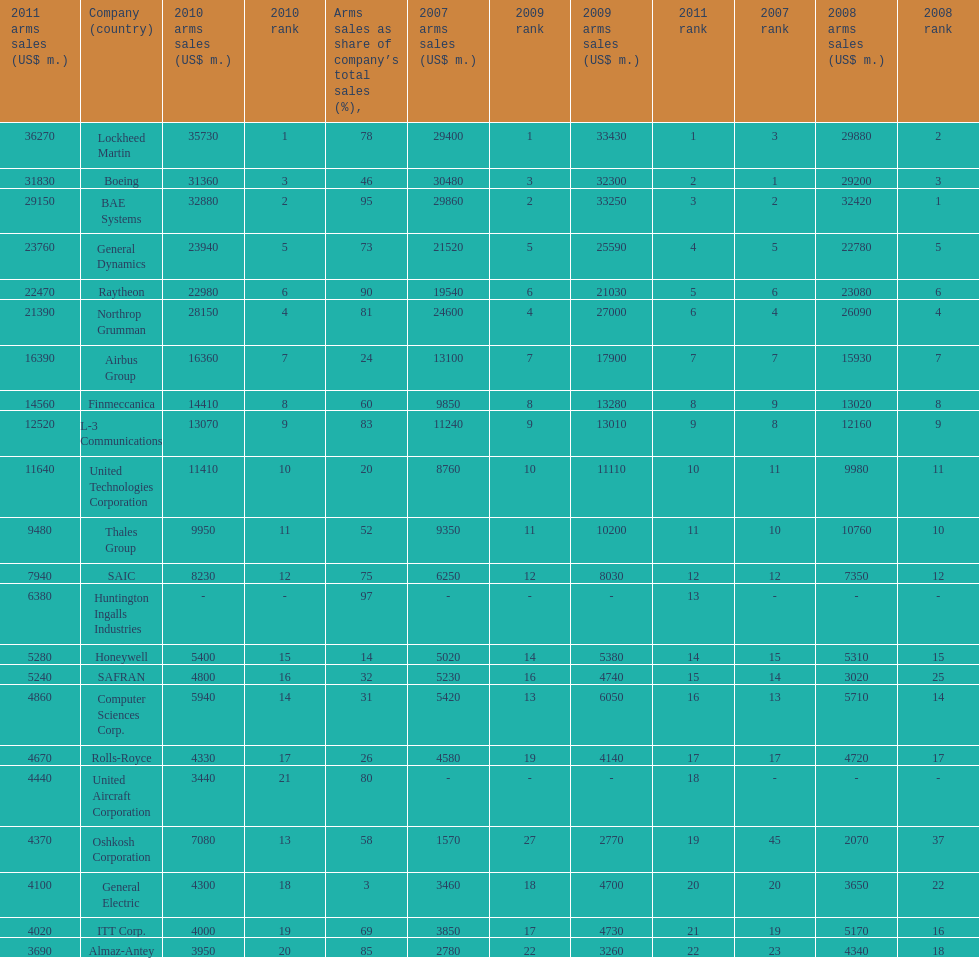Calculate the difference between boeing's 2010 arms sales and raytheon's 2010 arms sales. 8380. Would you be able to parse every entry in this table? {'header': ['2011 arms sales (US$ m.)', 'Company (country)', '2010 arms sales (US$ m.)', '2010 rank', 'Arms sales as share of company’s total sales (%),', '2007 arms sales (US$ m.)', '2009 rank', '2009 arms sales (US$ m.)', '2011 rank', '2007 rank', '2008 arms sales (US$ m.)', '2008 rank'], 'rows': [['36270', 'Lockheed Martin', '35730', '1', '78', '29400', '1', '33430', '1', '3', '29880', '2'], ['31830', 'Boeing', '31360', '3', '46', '30480', '3', '32300', '2', '1', '29200', '3'], ['29150', 'BAE Systems', '32880', '2', '95', '29860', '2', '33250', '3', '2', '32420', '1'], ['23760', 'General Dynamics', '23940', '5', '73', '21520', '5', '25590', '4', '5', '22780', '5'], ['22470', 'Raytheon', '22980', '6', '90', '19540', '6', '21030', '5', '6', '23080', '6'], ['21390', 'Northrop Grumman', '28150', '4', '81', '24600', '4', '27000', '6', '4', '26090', '4'], ['16390', 'Airbus Group', '16360', '7', '24', '13100', '7', '17900', '7', '7', '15930', '7'], ['14560', 'Finmeccanica', '14410', '8', '60', '9850', '8', '13280', '8', '9', '13020', '8'], ['12520', 'L-3 Communications', '13070', '9', '83', '11240', '9', '13010', '9', '8', '12160', '9'], ['11640', 'United Technologies Corporation', '11410', '10', '20', '8760', '10', '11110', '10', '11', '9980', '11'], ['9480', 'Thales Group', '9950', '11', '52', '9350', '11', '10200', '11', '10', '10760', '10'], ['7940', 'SAIC', '8230', '12', '75', '6250', '12', '8030', '12', '12', '7350', '12'], ['6380', 'Huntington Ingalls Industries', '-', '-', '97', '-', '-', '-', '13', '-', '-', '-'], ['5280', 'Honeywell', '5400', '15', '14', '5020', '14', '5380', '14', '15', '5310', '15'], ['5240', 'SAFRAN', '4800', '16', '32', '5230', '16', '4740', '15', '14', '3020', '25'], ['4860', 'Computer Sciences Corp.', '5940', '14', '31', '5420', '13', '6050', '16', '13', '5710', '14'], ['4670', 'Rolls-Royce', '4330', '17', '26', '4580', '19', '4140', '17', '17', '4720', '17'], ['4440', 'United Aircraft Corporation', '3440', '21', '80', '-', '-', '-', '18', '-', '-', '-'], ['4370', 'Oshkosh Corporation', '7080', '13', '58', '1570', '27', '2770', '19', '45', '2070', '37'], ['4100', 'General Electric', '4300', '18', '3', '3460', '18', '4700', '20', '20', '3650', '22'], ['4020', 'ITT Corp.', '4000', '19', '69', '3850', '17', '4730', '21', '19', '5170', '16'], ['3690', 'Almaz-Antey', '3950', '20', '85', '2780', '22', '3260', '22', '23', '4340', '18']]} 